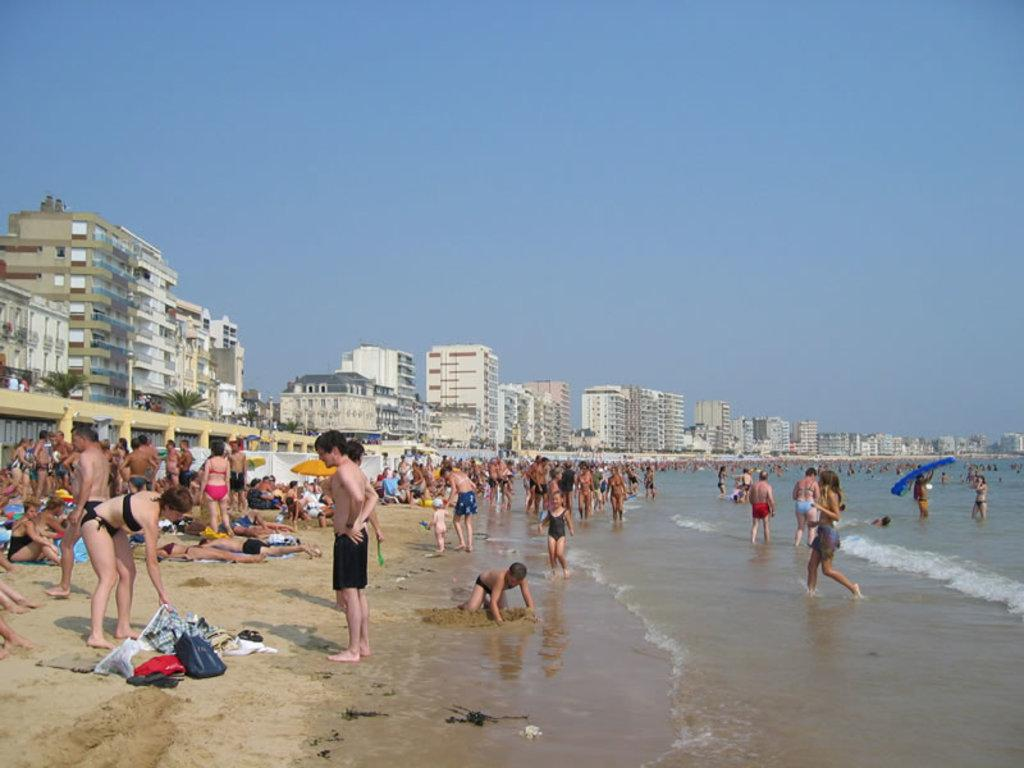What type of natural environment is depicted in the image? There is a sea shore in the image. What are the people on the sand doing? Some people are on the sand, and others are playing in the water. What structures can be seen in the image? There are buildings visible in the image. What type of vegetation is present in the image? Trees are present in the image. What shape is the notebook on the moon in the image? There is no notebook or moon present in the image; it features a sea shore with people and buildings. 